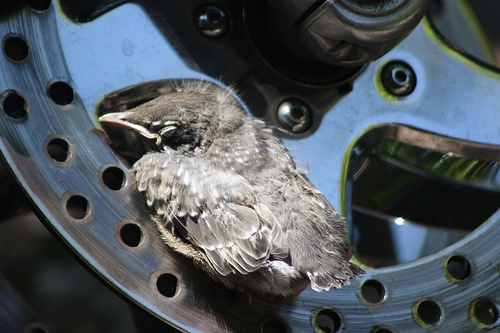Describe the objects in this image and their specific colors. I can see a bird in black, darkgray, lightgray, and gray tones in this image. 